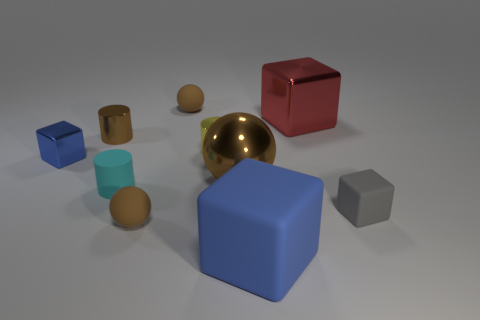How many objects are either shiny blocks in front of the large red metal object or purple metal things?
Provide a succinct answer. 1. There is a shiny cylinder that is on the right side of the matte cylinder; is its size the same as the gray rubber object?
Your answer should be very brief. Yes. Is the number of cyan rubber objects in front of the large sphere less than the number of small blue blocks?
Ensure brevity in your answer.  No. There is a blue cube that is the same size as the red cube; what is it made of?
Provide a short and direct response. Rubber. What number of big objects are yellow matte balls or yellow cylinders?
Make the answer very short. 0. How many objects are either matte things that are behind the small gray cube or blue blocks that are to the left of the yellow shiny thing?
Your answer should be very brief. 3. Is the number of large blue matte cubes less than the number of large gray rubber cylinders?
Your answer should be compact. No. The brown metallic thing that is the same size as the red cube is what shape?
Offer a terse response. Sphere. What number of other objects are there of the same color as the big ball?
Offer a very short reply. 3. How many brown metal objects are there?
Keep it short and to the point. 2. 